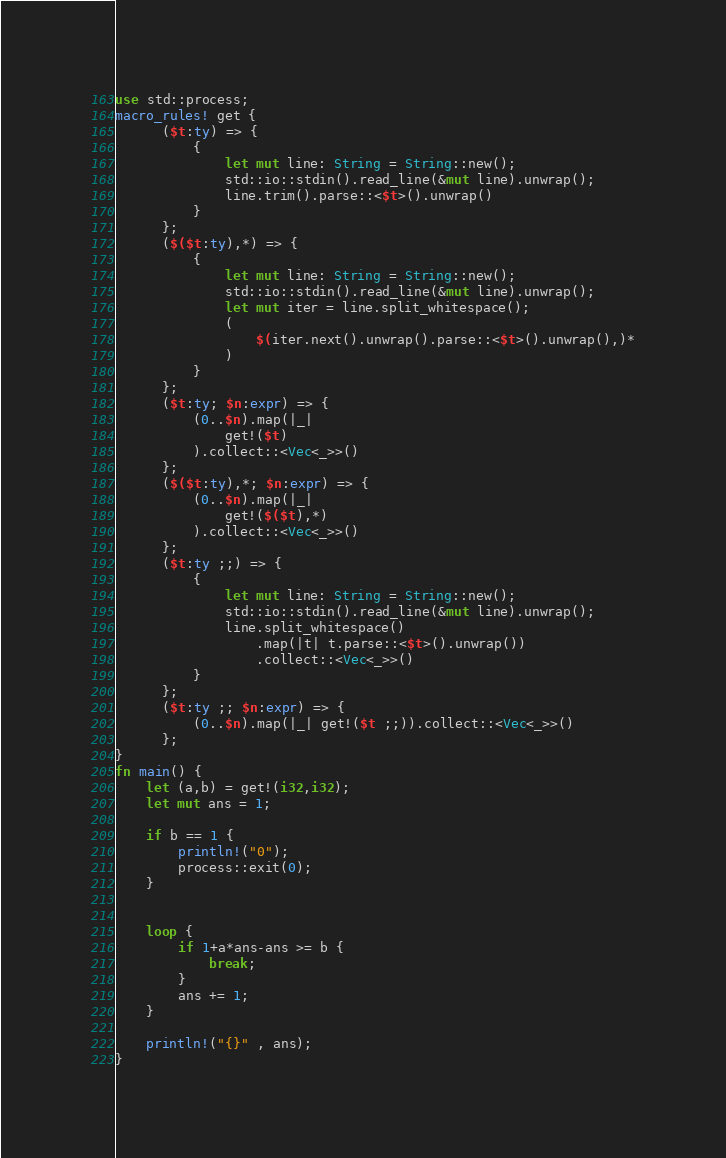<code> <loc_0><loc_0><loc_500><loc_500><_Rust_>use std::process;
macro_rules! get {
      ($t:ty) => {
          {
              let mut line: String = String::new();
              std::io::stdin().read_line(&mut line).unwrap();
              line.trim().parse::<$t>().unwrap()
          }
      };
      ($($t:ty),*) => {
          {
              let mut line: String = String::new();
              std::io::stdin().read_line(&mut line).unwrap();
              let mut iter = line.split_whitespace();
              (
                  $(iter.next().unwrap().parse::<$t>().unwrap(),)*
              )
          }
      };
      ($t:ty; $n:expr) => {
          (0..$n).map(|_|
              get!($t)
          ).collect::<Vec<_>>()
      };
      ($($t:ty),*; $n:expr) => {
          (0..$n).map(|_|
              get!($($t),*)
          ).collect::<Vec<_>>()
      };
      ($t:ty ;;) => {
          {
              let mut line: String = String::new();
              std::io::stdin().read_line(&mut line).unwrap();
              line.split_whitespace()
                  .map(|t| t.parse::<$t>().unwrap())
                  .collect::<Vec<_>>()
          }
      };
      ($t:ty ;; $n:expr) => {
          (0..$n).map(|_| get!($t ;;)).collect::<Vec<_>>()
      };
}
fn main() {
    let (a,b) = get!(i32,i32);
    let mut ans = 1;

    if b == 1 {
        println!("0");
        process::exit(0);
    }


    loop {
        if 1+a*ans-ans >= b {
            break;
        }
        ans += 1;
    }
    
    println!("{}" , ans);
}
</code> 